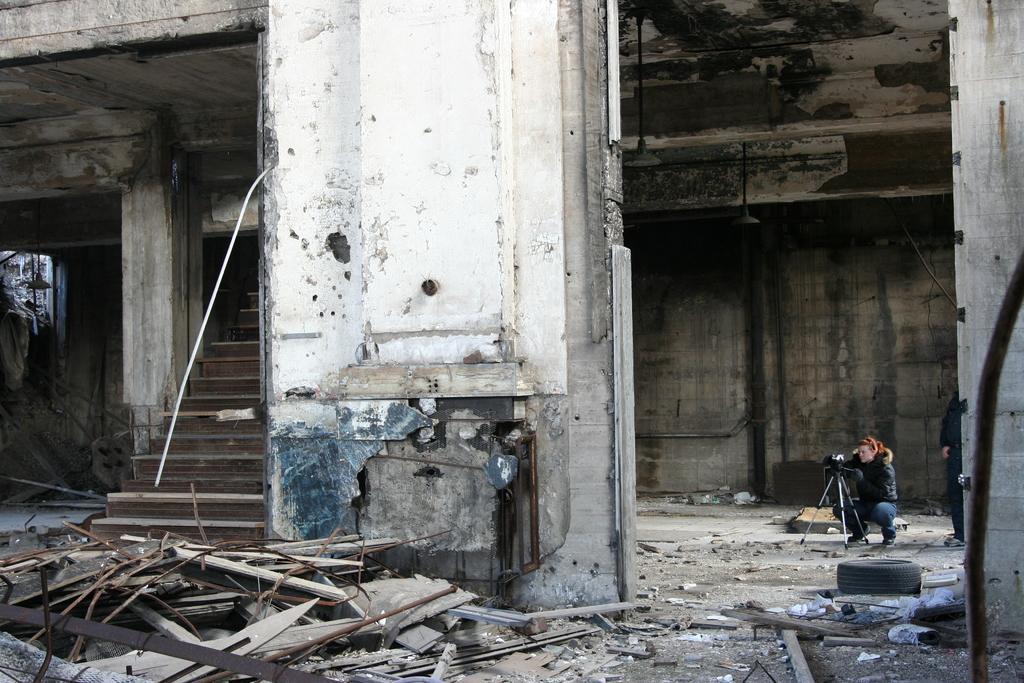In one or two sentences, can you explain what this image depicts? At the bottom of the picture, we see the wooden sticks and rods. In the middle, we see a pillar. On the right side, we see a man is in squad position. In front of him, we see a camera stand. Beside him, we see a man is standing. In front of them, we see the tyre of the car. On the right side, we see a pillar and a rod. In the background, we see a building which is under construction. On the left side, we see a pillar and the staircase. 